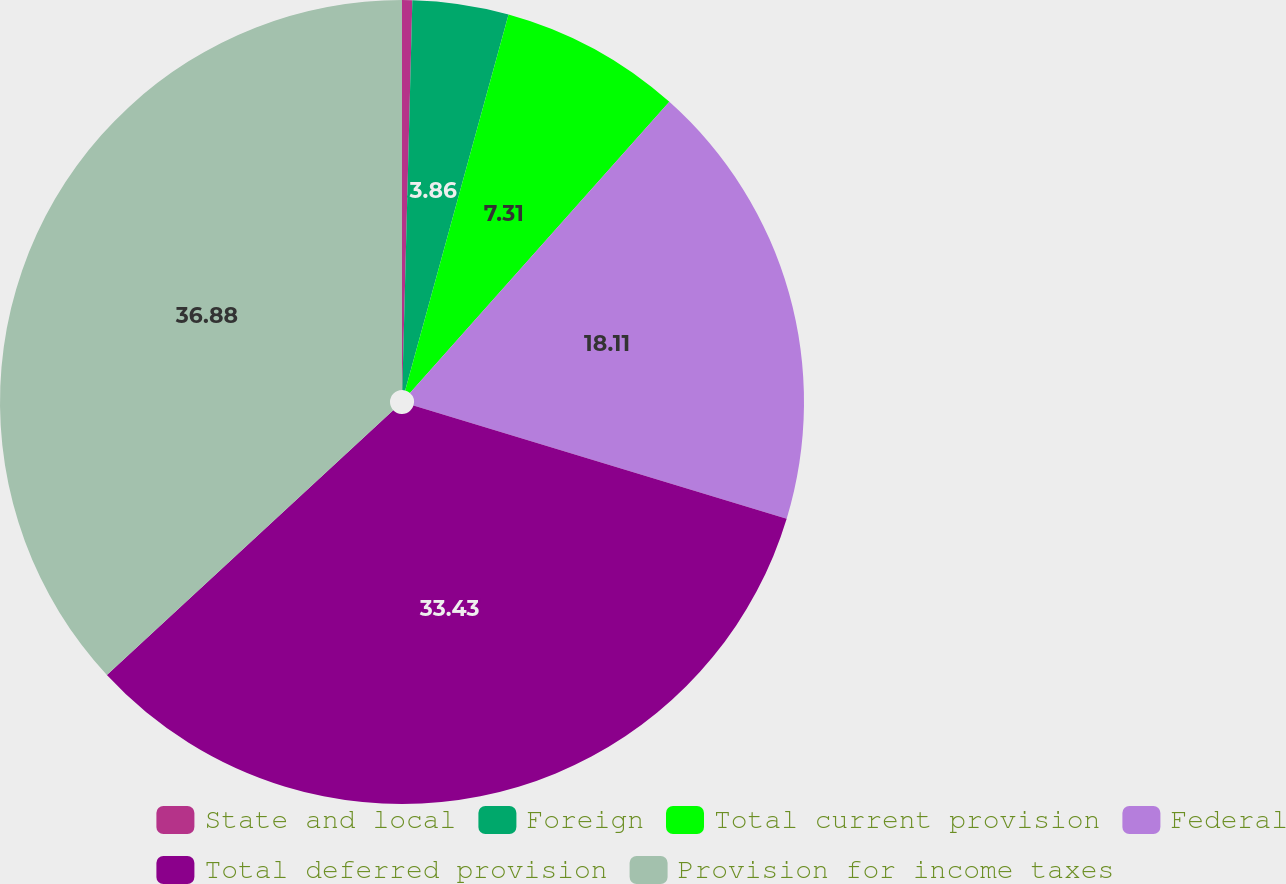Convert chart to OTSL. <chart><loc_0><loc_0><loc_500><loc_500><pie_chart><fcel>State and local<fcel>Foreign<fcel>Total current provision<fcel>Federal<fcel>Total deferred provision<fcel>Provision for income taxes<nl><fcel>0.41%<fcel>3.86%<fcel>7.31%<fcel>18.11%<fcel>33.43%<fcel>36.88%<nl></chart> 